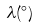<formula> <loc_0><loc_0><loc_500><loc_500>\lambda ( ^ { \circ } )</formula> 